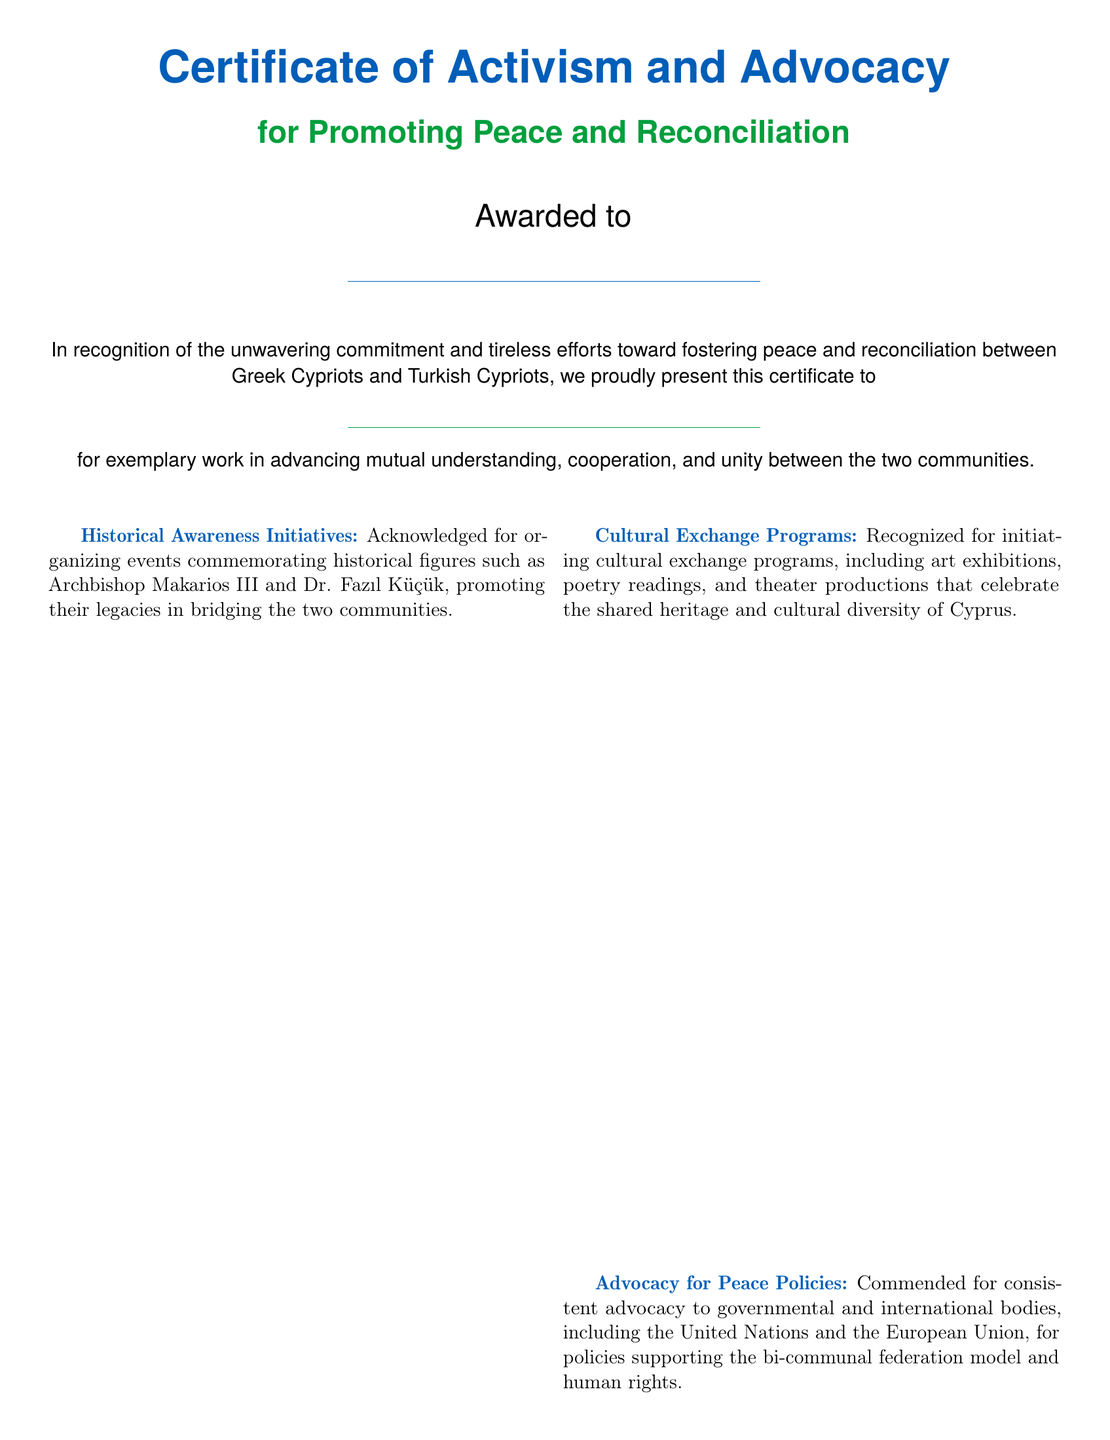What is the title of the certificate? The title is prominently displayed at the top of the document.
Answer: Certificate of Activism and Advocacy Who is the certificate awarded to? The document includes a placeholder for the recipient's name.
Answer: \underline{\hspace{8cm}} What is recognized by this certificate? The certificate acknowledges efforts in promoting peace and reconciliation.
Answer: unwavering commitment and tireless efforts What are the two communities mentioned? The document specifies both communities involved in the reconciliation effort.
Answer: Greek Cypriots and Turkish Cypriots What kind of initiatives are acknowledged in the certificate? The certificate lists various contributions made towards peace efforts.
Answer: Historical Awareness Initiatives What policies does the advocacy mention in the document? The advocacy section refers to specific types of political support.
Answer: bi-communal federation model How is grassroots mobilization described? This section details the nature of engagement with local communities.
Answer: involving local communities in dialogue sessions What does this certificate encourage recipients to do? The conclusion of the document states a specific ongoing action.
Answer: continued dedication to the cause of peace and reconciliation 